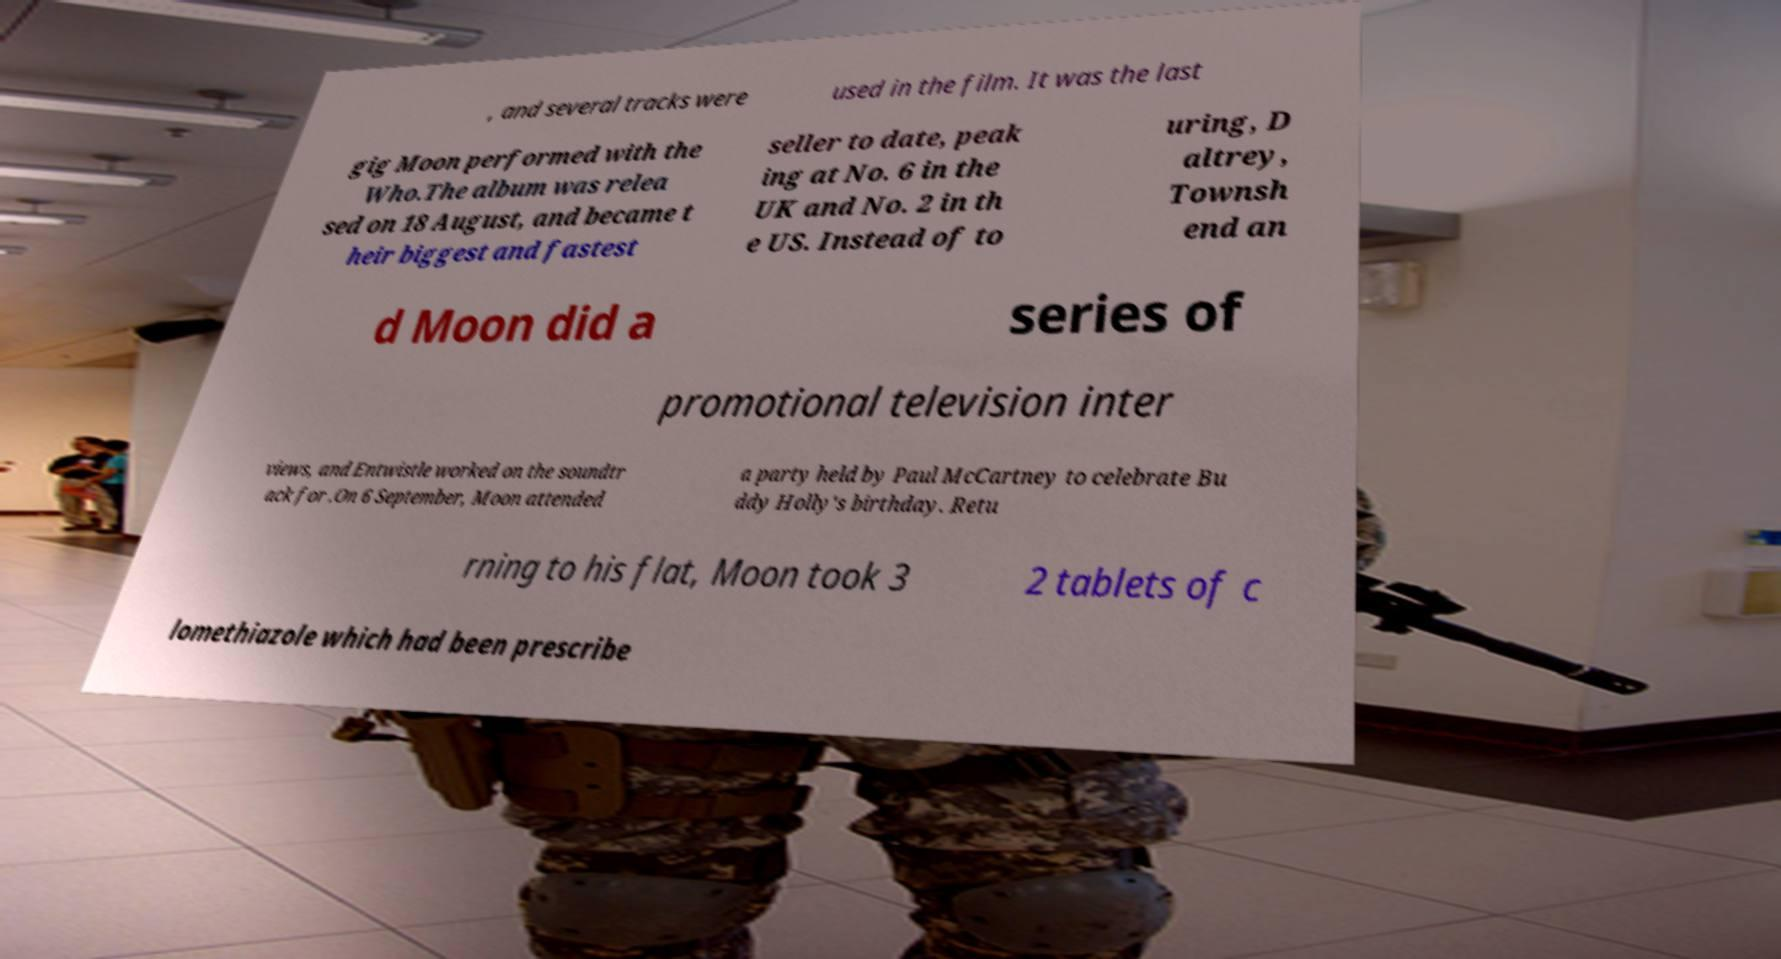Can you accurately transcribe the text from the provided image for me? , and several tracks were used in the film. It was the last gig Moon performed with the Who.The album was relea sed on 18 August, and became t heir biggest and fastest seller to date, peak ing at No. 6 in the UK and No. 2 in th e US. Instead of to uring, D altrey, Townsh end an d Moon did a series of promotional television inter views, and Entwistle worked on the soundtr ack for .On 6 September, Moon attended a party held by Paul McCartney to celebrate Bu ddy Holly's birthday. Retu rning to his flat, Moon took 3 2 tablets of c lomethiazole which had been prescribe 